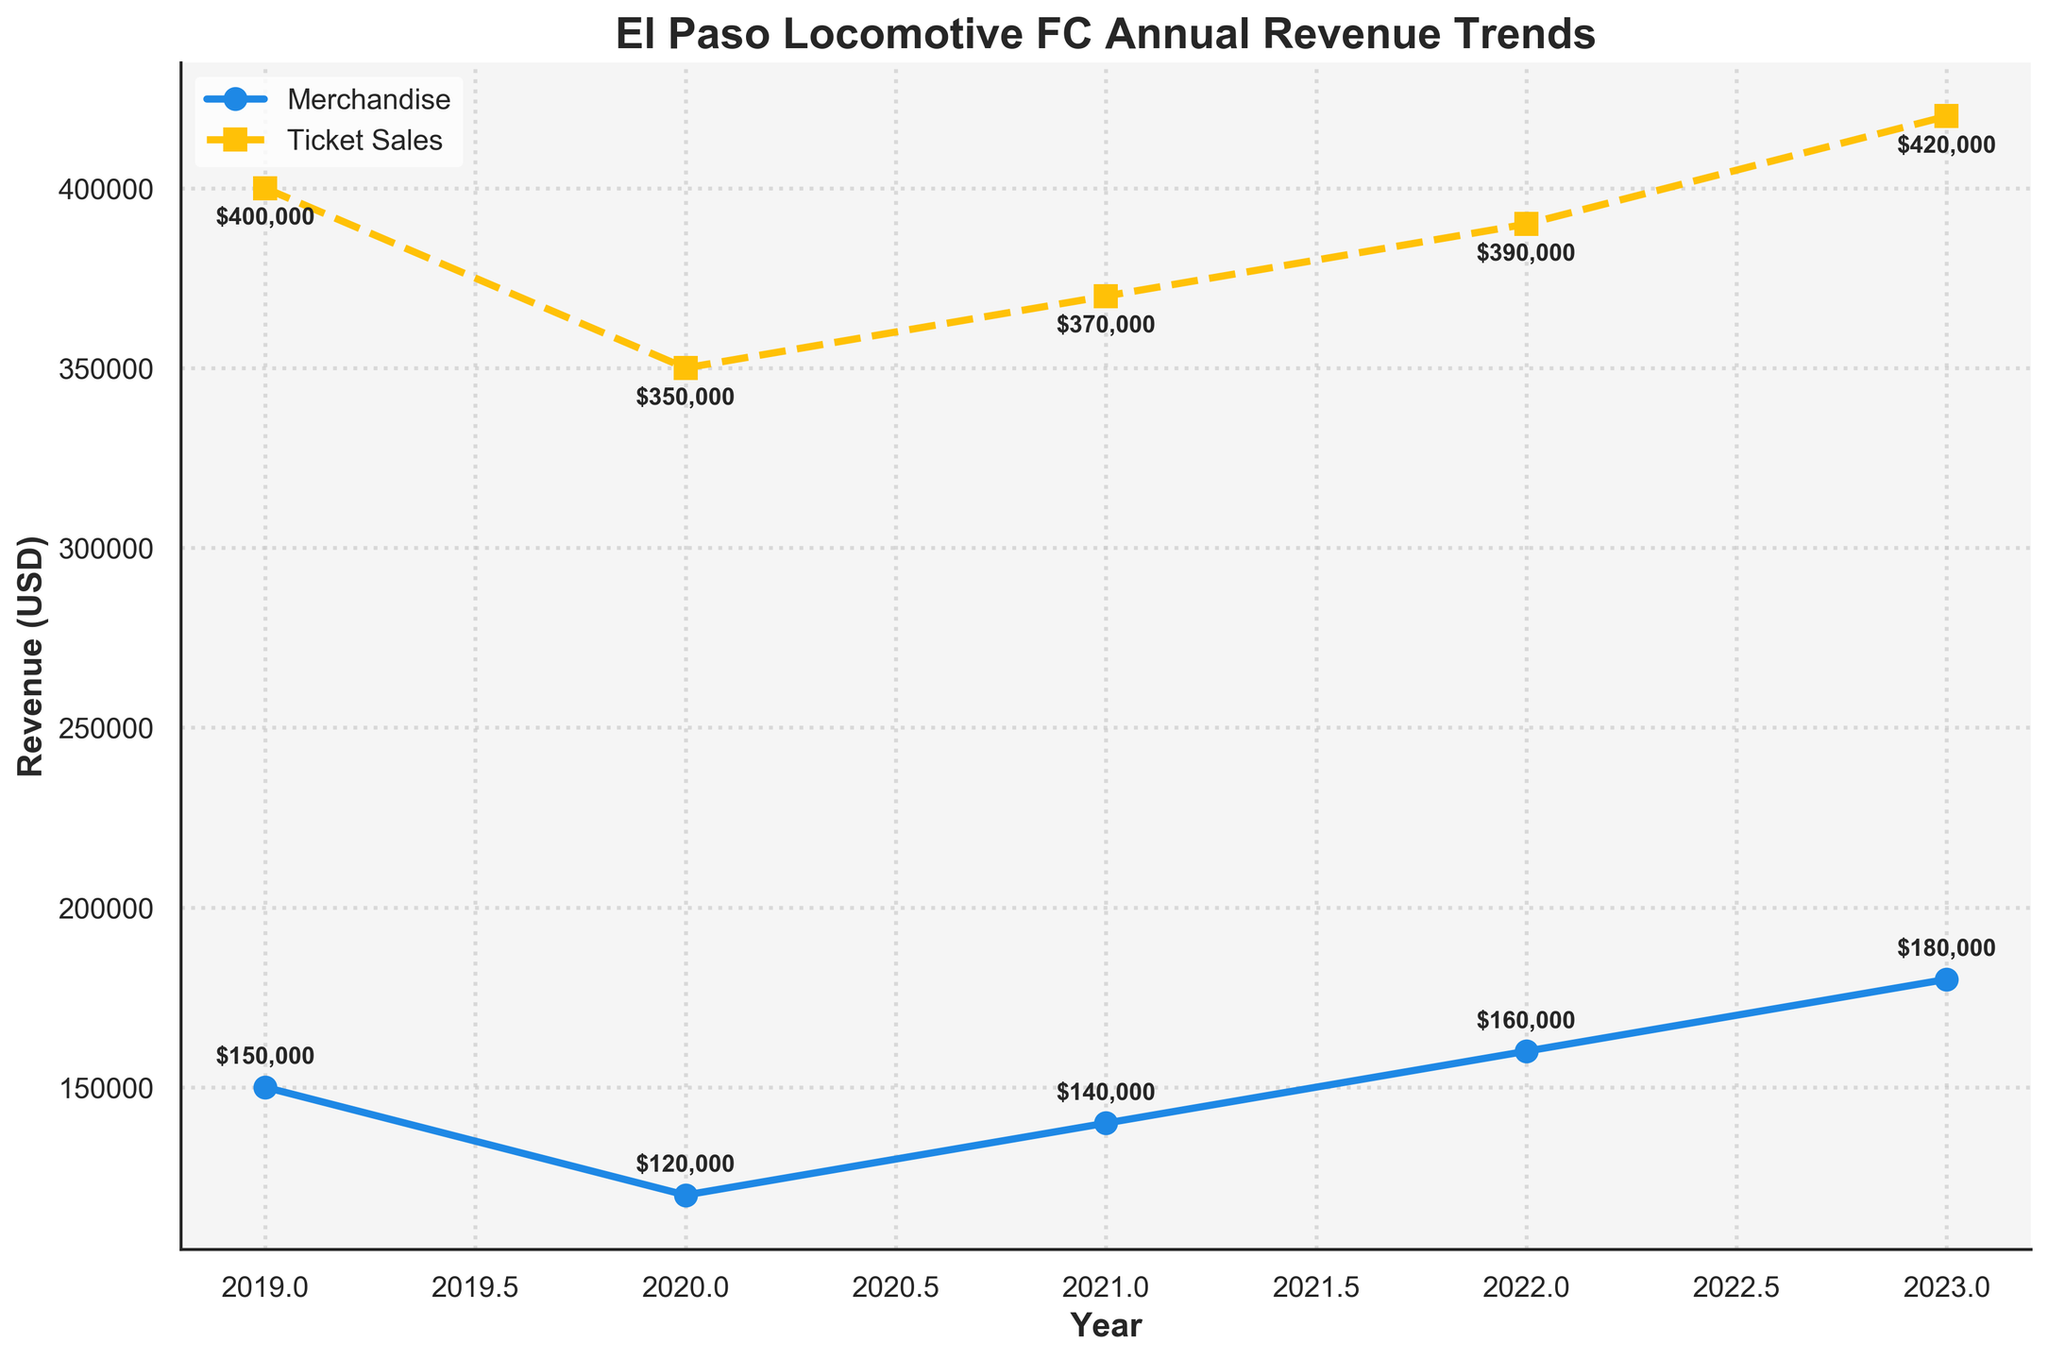What is the title of the figure? The title of the figure is written at the top, describing the overall subject of the plot.
Answer: El Paso Locomotive FC Annual Revenue Trends How many years of data are shown in the plot? Count the number of data points on the x-axis, one for each year.
Answer: 5 What were the merchandise and ticket sales revenues in 2023? Look at the two data points for the year 2023 and read their respective values.
Answer: $180,000 for Merchandise and $420,000 for Ticket Sales In which year did ticket sales revenue see the lowest value? Identify the year where the ticket sales line reaches its lowest point.
Answer: 2020 How much did merchandise revenue increase from 2022 to 2023? Subtract the merchandise revenue of 2022 from that of 2023.
Answer: $20,000 By how much did ticket sales revenue increase from 2019 to 2023? Subtract the ticket sales revenue of 2019 from that of 2023.
Answer: $20,000 Which type of revenue grew faster between 2020 and 2023? Compare merchandise and ticket sales revenue changes from 2020 to 2023 by looking at the slope of the respective lines.
Answer: Merchandise Revenue What is the difference in revenues between merchandise and ticket sales in 2021? Subtract the merchandise revenue from the ticket sales revenue for 2021.
Answer: $230,000 Which revenue type showed a more consistent growth pattern over the years? Assess the linearity of the trendlines for both revenues over the years.
Answer: Ticket Sales Revenue How do the trends in merchandise revenue compare to ticket sales revenue over the 5-year period? Analyze the general direction and changes in the slopes of the lines for both revenue types over the years.
Answer: Both show an overall increase, but ticket sales grew more consistently 